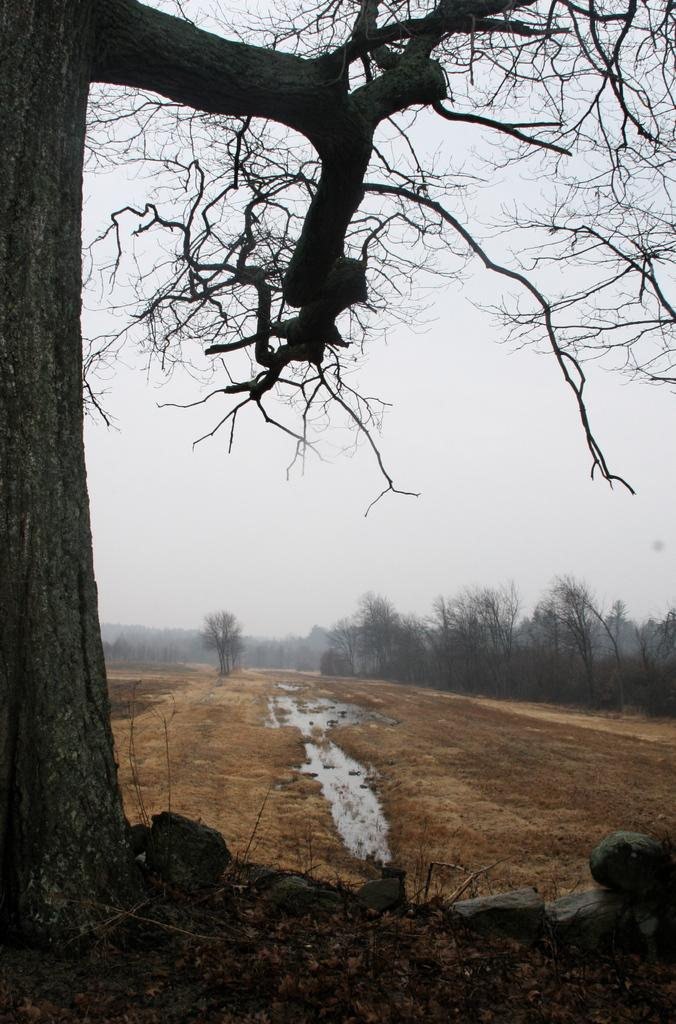What type of vegetation can be seen in the image? There are trees in the image. What body of water is present in the image? There is a pond at the bottom of the image. What part of the natural environment is visible in the background of the image? The sky is visible in the background of the image. What type of geological feature can be seen in the bottom right of the image? There are rocks in the bottom right of the image. Where is the baby in the image? There is no baby present in the image. What type of town can be seen in the image? There is no town present in the image; it features trees, a pond, rocks, and the sky. 